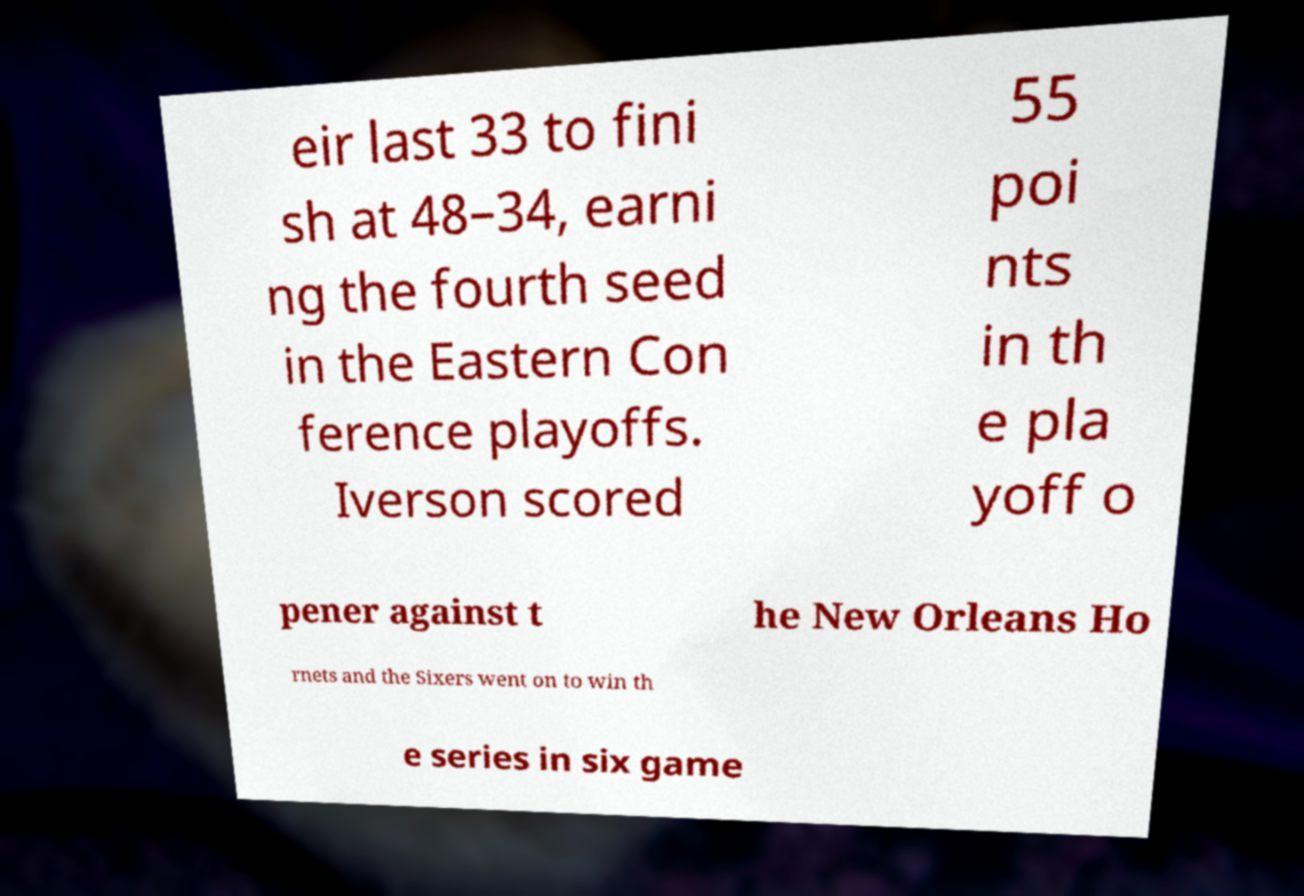Could you assist in decoding the text presented in this image and type it out clearly? eir last 33 to fini sh at 48–34, earni ng the fourth seed in the Eastern Con ference playoffs. Iverson scored 55 poi nts in th e pla yoff o pener against t he New Orleans Ho rnets and the Sixers went on to win th e series in six game 